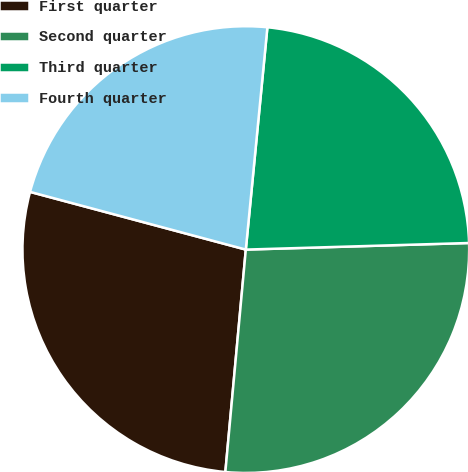<chart> <loc_0><loc_0><loc_500><loc_500><pie_chart><fcel>First quarter<fcel>Second quarter<fcel>Third quarter<fcel>Fourth quarter<nl><fcel>27.7%<fcel>26.93%<fcel>22.99%<fcel>22.38%<nl></chart> 